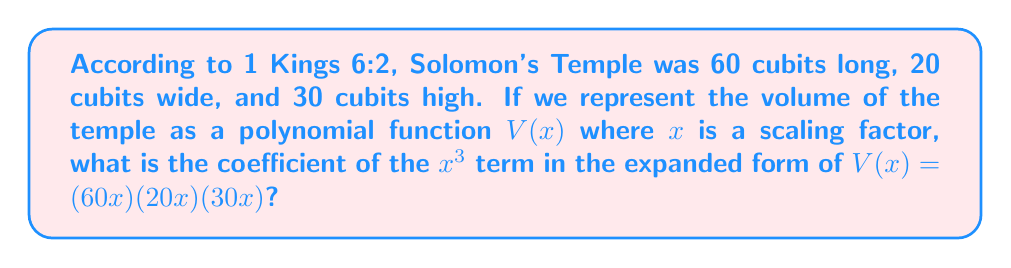Can you solve this math problem? Let's approach this step-by-step:

1) The volume of a rectangular prism is given by the product of its length, width, and height.

2) In this case, we have:
   $V(x) = (60x)(20x)(30x)$

3) Let's expand this:
   $V(x) = 60x \cdot 20x \cdot 30x$
   $V(x) = 36000x^3$

4) In the expanded form, the coefficient of $x^3$ is 36000.

5) To understand this in the context of Solomon's Temple:
   - The scaling factor $x$ allows us to adjust the size of the temple while maintaining its proportions.
   - When $x = 1$, we get the actual volume of Solomon's Temple in cubic cubits.
   - The coefficient 36000 represents the volume of the temple if it were 1 cubit in each dimension, scaled up by a factor of 36000.

This polynomial representation allows us to easily calculate the volume for any scaling of the original dimensions, which could be useful in architectural or historical studies.
Answer: 36000 